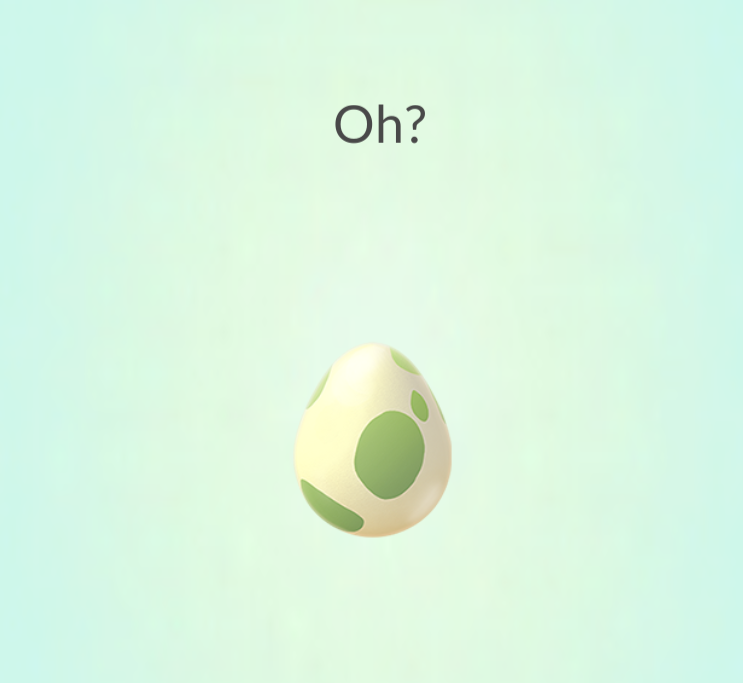Based on the design and presentation of the egg, what type of virtual environment or game do you think this egg is associated with, and what might be the significance of the word "Oh?" appearing above it? The egg's design and the overall aesthetic of the image suggest that it is associated with a family-friendly, possibly augmented reality (AR) game environment. Given the context of the word "Oh?" which typically signifies an event or a reveal, it is likely that the egg is about to hatch within the game. The anticipation created by the text suggests that players are meant to feel curious and excited about what creature or item will emerge from the egg. 